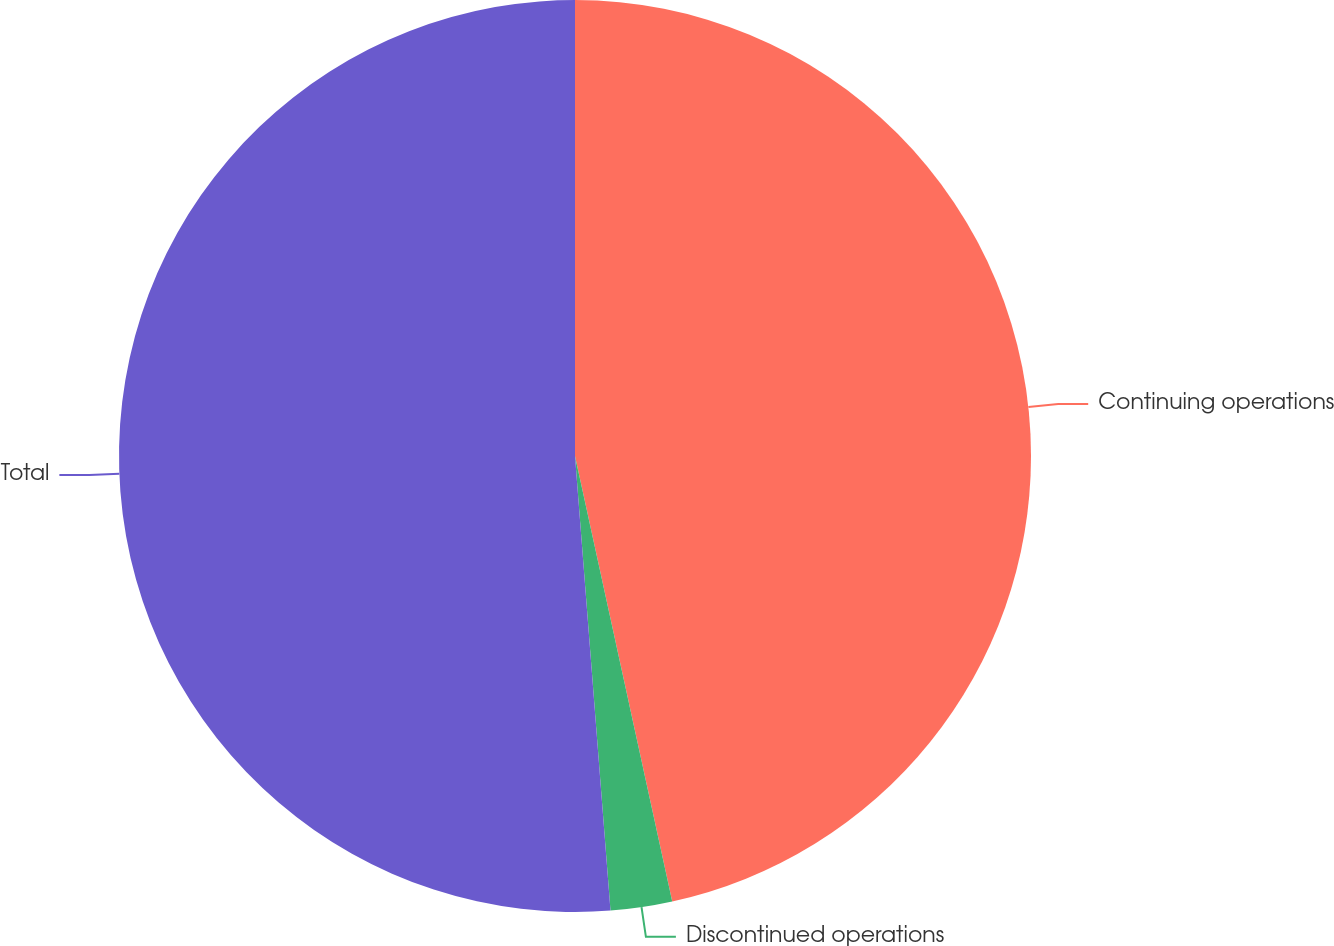<chart> <loc_0><loc_0><loc_500><loc_500><pie_chart><fcel>Continuing operations<fcel>Discontinued operations<fcel>Total<nl><fcel>46.58%<fcel>2.18%<fcel>51.24%<nl></chart> 